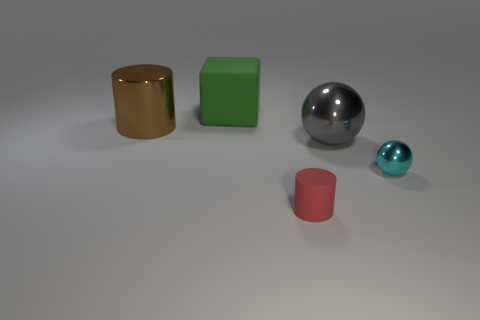What number of rubber things are the same size as the gray metal thing?
Provide a short and direct response. 1. Is the number of big spheres that are on the right side of the small matte cylinder greater than the number of big brown cylinders that are left of the large brown metal cylinder?
Your answer should be compact. Yes. The rubber object that is behind the cylinder that is on the left side of the matte cube is what color?
Give a very brief answer. Green. Do the tiny cyan ball and the green thing have the same material?
Give a very brief answer. No. Are there any gray metallic things that have the same shape as the tiny cyan shiny thing?
Keep it short and to the point. Yes. Is the size of the cylinder that is behind the small shiny sphere the same as the thing behind the brown metallic thing?
Give a very brief answer. Yes. What size is the cylinder that is the same material as the large gray sphere?
Ensure brevity in your answer.  Large. What number of objects are on the left side of the small metallic object and in front of the brown metallic cylinder?
Your answer should be compact. 2. How many things are tiny gray cylinders or things to the right of the cube?
Offer a very short reply. 3. There is a cylinder behind the small cyan sphere; what color is it?
Offer a very short reply. Brown. 